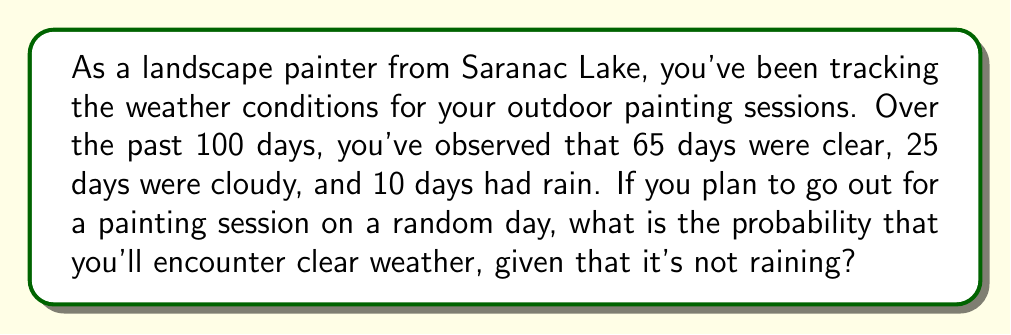What is the answer to this math problem? To solve this problem, we'll use conditional probability. We need to find the probability of clear weather given that it's not raining.

Let's define our events:
C: Clear weather
N: Not raining

We want to find P(C|N), which is the probability of clear weather given that it's not raining.

We can use the formula for conditional probability:

$$P(C|N) = \frac{P(C \cap N)}{P(N)}$$

First, let's calculate P(N), the probability of not raining:
Total days = 100
Days not raining = 65 (clear) + 25 (cloudy) = 90
$$P(N) = \frac{90}{100} = 0.9$$

Now, P(C ∩ N) is simply the probability of clear weather, as clear days are already not raining:
$$P(C \cap N) = \frac{65}{100} = 0.65$$

Plugging these values into our conditional probability formula:

$$P(C|N) = \frac{P(C \cap N)}{P(N)} = \frac{0.65}{0.9} = \frac{13}{18} \approx 0.7222$$
Answer: The probability of encountering clear weather for a painting session, given that it's not raining, is $\frac{13}{18}$ or approximately 0.7222 (72.22%). 